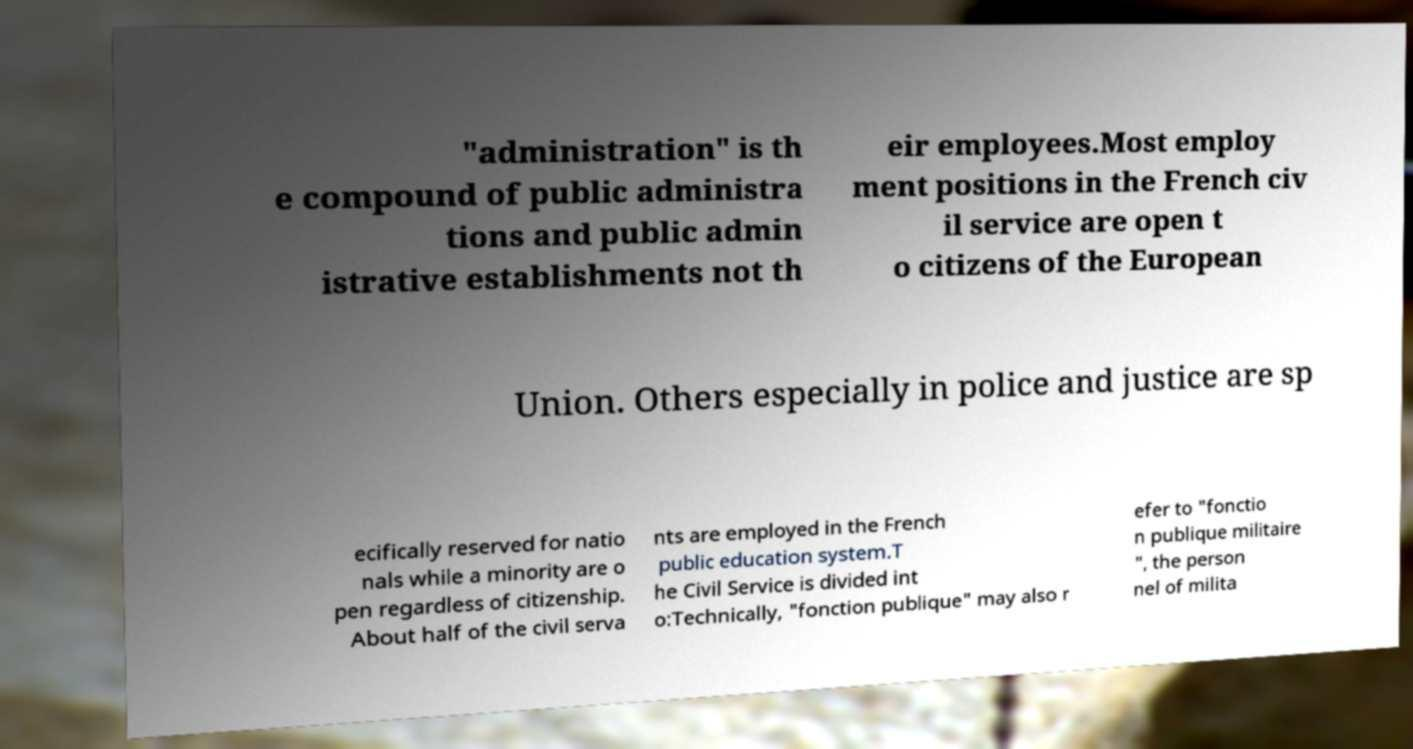Please read and relay the text visible in this image. What does it say? "administration" is th e compound of public administra tions and public admin istrative establishments not th eir employees.Most employ ment positions in the French civ il service are open t o citizens of the European Union. Others especially in police and justice are sp ecifically reserved for natio nals while a minority are o pen regardless of citizenship. About half of the civil serva nts are employed in the French public education system.T he Civil Service is divided int o:Technically, "fonction publique" may also r efer to "fonctio n publique militaire ", the person nel of milita 